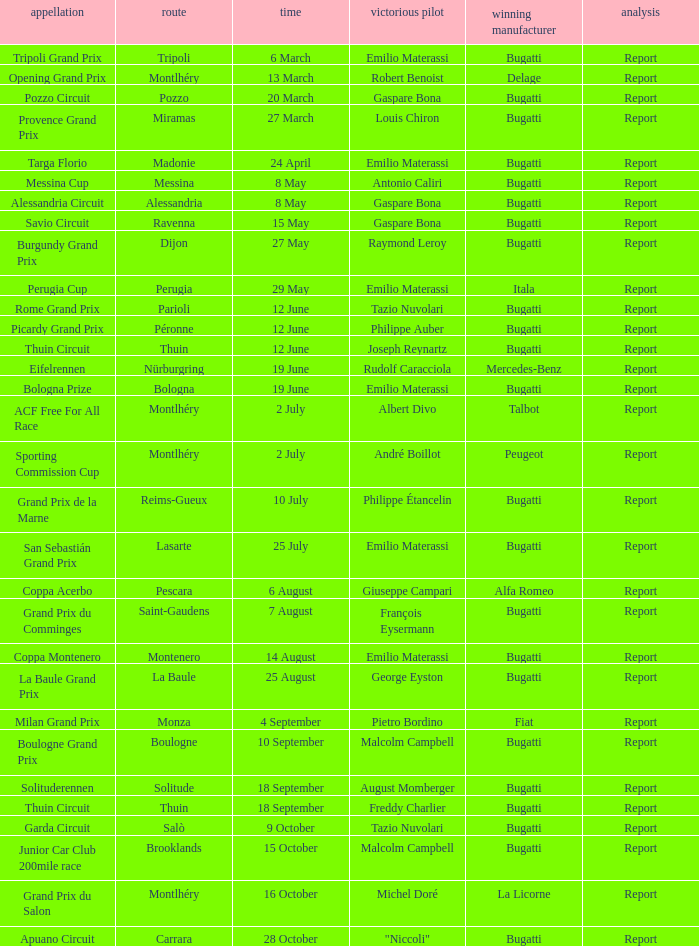Who was the winning constructor of the Grand Prix Du Salon ? La Licorne. 